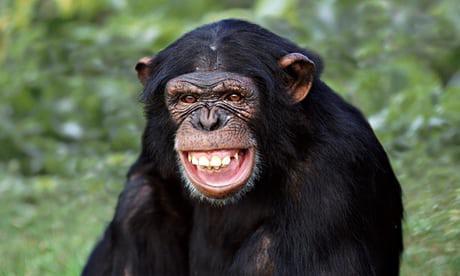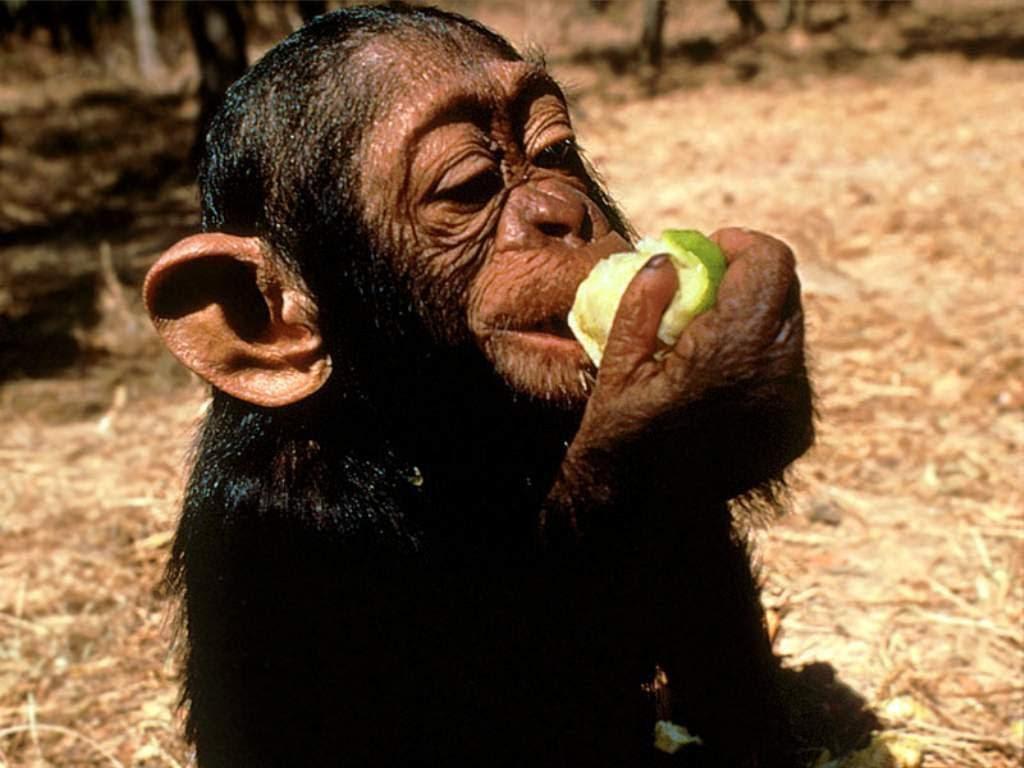The first image is the image on the left, the second image is the image on the right. Examine the images to the left and right. Is the description "At least one chimp has something to eat in each image, and no chimp is using cutlery to eat." accurate? Answer yes or no. No. The first image is the image on the left, the second image is the image on the right. For the images shown, is this caption "One of the monkeys is not eating." true? Answer yes or no. Yes. 